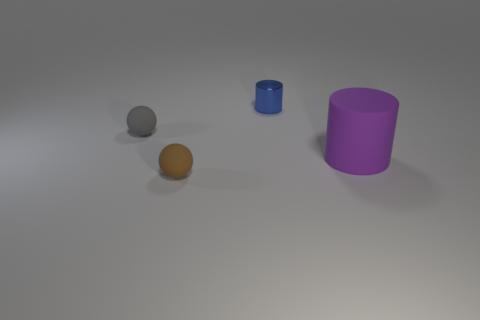Is the number of purple matte cylinders to the left of the tiny gray matte thing greater than the number of brown objects that are in front of the large matte object?
Offer a very short reply. No. What number of brown rubber things have the same size as the blue cylinder?
Offer a very short reply. 1. Is the number of blue metal things that are in front of the purple rubber cylinder less than the number of small brown matte things that are behind the small gray object?
Provide a succinct answer. No. Is there a blue object of the same shape as the gray object?
Your response must be concise. No. Is the tiny gray thing the same shape as the brown rubber thing?
Ensure brevity in your answer.  Yes. What number of large things are blue rubber cylinders or metal objects?
Your answer should be very brief. 0. Are there more objects than purple things?
Provide a short and direct response. Yes. There is a brown ball that is the same material as the big purple thing; what is its size?
Provide a short and direct response. Small. Do the cylinder that is behind the big thing and the object that is in front of the big purple rubber cylinder have the same size?
Provide a short and direct response. Yes. How many objects are either small spheres that are behind the brown rubber ball or small blue metal cylinders?
Offer a very short reply. 2. 